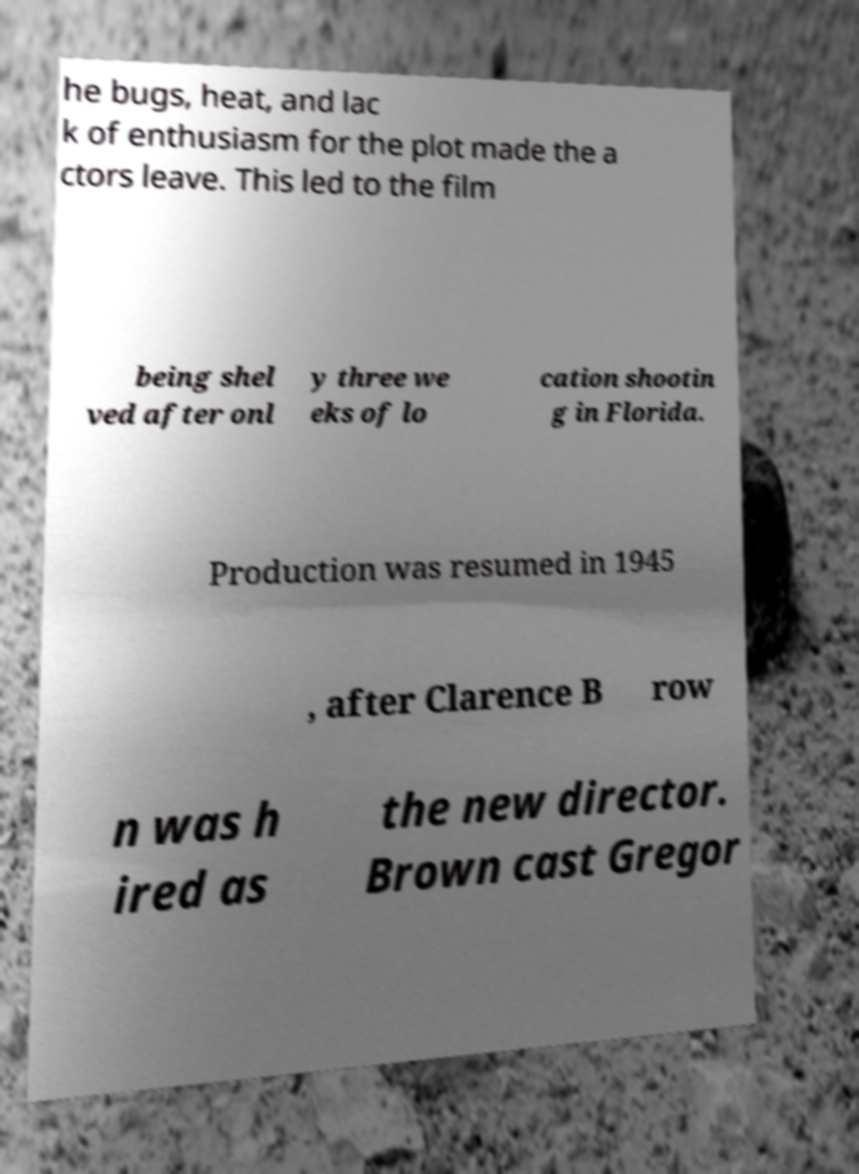Can you accurately transcribe the text from the provided image for me? he bugs, heat, and lac k of enthusiasm for the plot made the a ctors leave. This led to the film being shel ved after onl y three we eks of lo cation shootin g in Florida. Production was resumed in 1945 , after Clarence B row n was h ired as the new director. Brown cast Gregor 